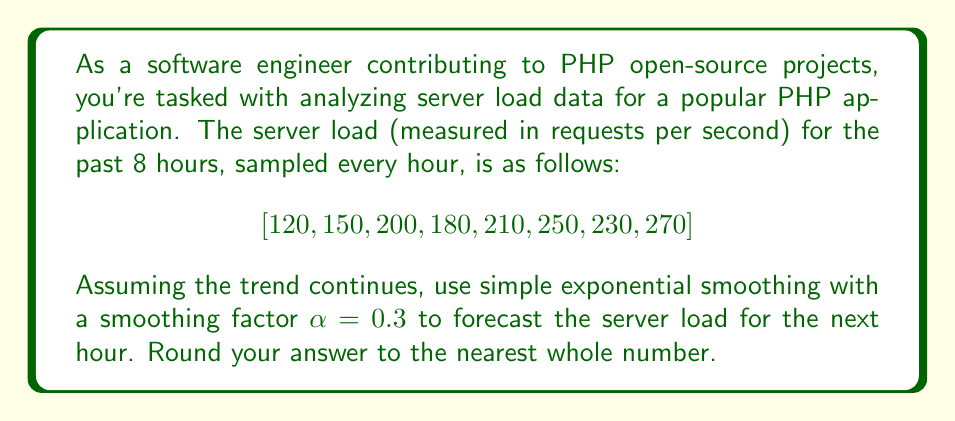Could you help me with this problem? To solve this problem, we'll use simple exponential smoothing, which is a common method for short-term forecasting in time series analysis. The formula for simple exponential smoothing is:

$$F_{t+1} = \alpha Y_t + (1-\alpha)F_t$$

Where:
$F_{t+1}$ is the forecast for the next period
$\alpha$ is the smoothing factor (given as 0.3)
$Y_t$ is the actual value at time t
$F_t$ is the forecast for the current period

We'll start by calculating the forecast for each period:

1) For t = 1: $F_1 = Y_1 = 120$ (we start with the first actual value)
2) For t = 2: $F_2 = 0.3 \times 150 + 0.7 \times 120 = 129$
3) For t = 3: $F_3 = 0.3 \times 200 + 0.7 \times 129 = 150.3$
4) For t = 4: $F_4 = 0.3 \times 180 + 0.7 \times 150.3 = 159.21$
5) For t = 5: $F_5 = 0.3 \times 210 + 0.7 \times 159.21 = 174.447$
6) For t = 6: $F_6 = 0.3 \times 250 + 0.7 \times 174.447 = 197.1129$
7) For t = 7: $F_7 = 0.3 \times 230 + 0.7 \times 197.1129 = 206.97903$
8) For t = 8: $F_8 = 0.3 \times 270 + 0.7 \times 206.97903 = 225.88532$

Now, to forecast for the next hour (t = 9), we use the last actual value and the last forecast:

$$F_9 = 0.3 \times 270 + 0.7 \times 225.88532 = 239.11972$$

Rounding to the nearest whole number, we get 239.
Answer: 239 requests per second 